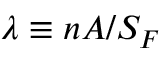Convert formula to latex. <formula><loc_0><loc_0><loc_500><loc_500>\lambda \equiv n A / S _ { F }</formula> 